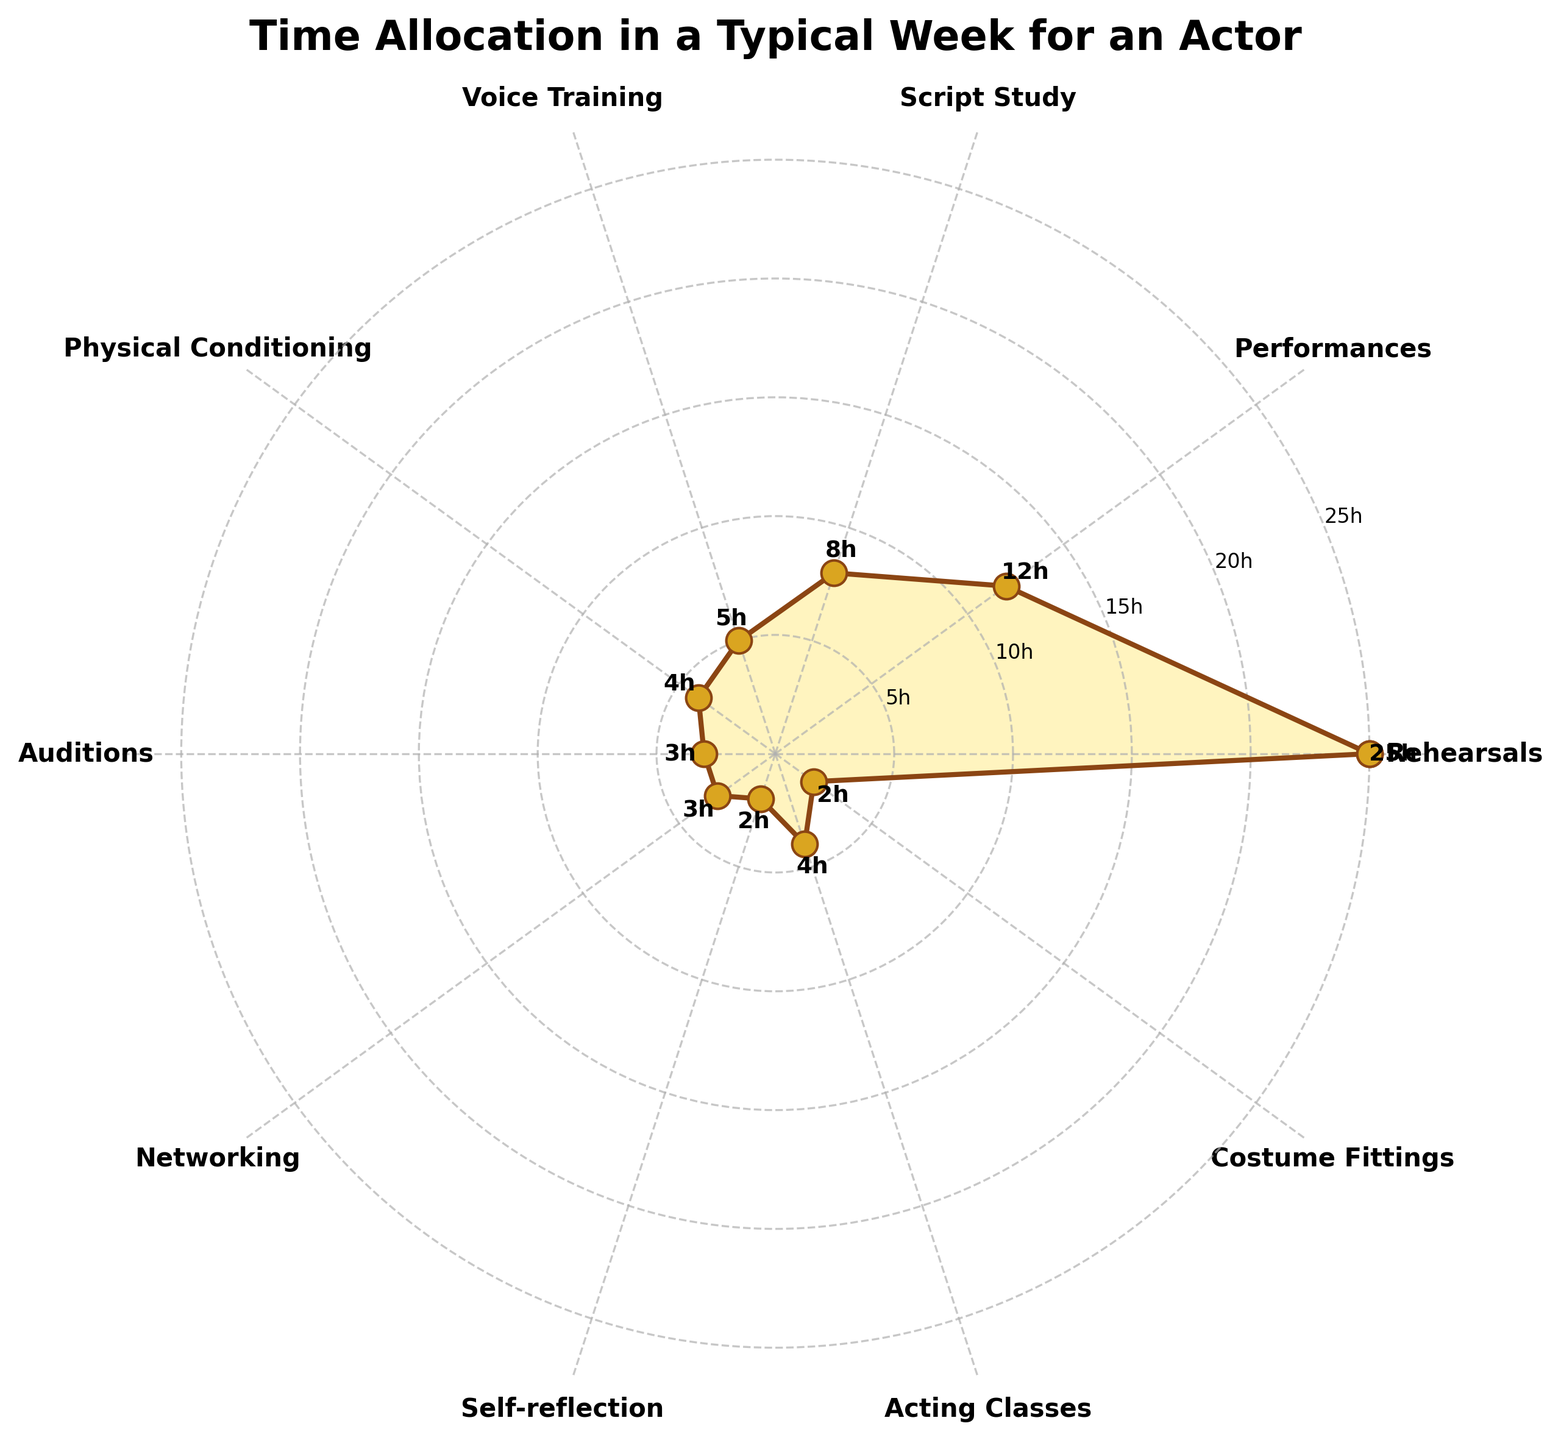What is the title of the figure? The title of the figure is written at the top. It is "Time Allocation in a Typical Week for an Actor".
Answer: Time Allocation in a Typical Week for an Actor How many activities are listed in the figure? By counting the distinct labels on the outer ring of the polar plot, we see there are 10 different activities listed.
Answer: 10 Which activity takes the most amount of time in a typical week? By observing the lengths of the spikes from the center of the polar chart, the "Rehearsals" spike is the longest, indicating it takes the most time.
Answer: Rehearsals What are the cumulative hours spent on Voice Training and Physical Conditioning? The hours spent on Voice Training and Physical Conditioning are 5 and 4, respectively. Adding these gives 5 + 4 = 9 hours.
Answer: 9 hours Which activity has the smallest allocation of hours, and how many hours are allocated to it? The shortest spike on the chart corresponds to "Self-reflection" and "Costume Fittings", which both have 2 hours.
Answer: Self-reflection and Costume Fittings, 2 hours each How much time is allocated to performances compared to script study? The line segment for Performances reaches 12 hours, while the line segment for Script Study reaches 8 hours. 12 - 8 = 4 hours more for Performances.
Answer: 4 hours more How many activities are allocated exactly 4 hours in a week? The labels closest to the 4-hour mark indicate that "Acting Classes" and "Physical Conditioning" are both allocated exactly 4 hours each.
Answer: 2 activities On average, how many hours are spent on activities related to personal development (including Voice Training, Physical Conditioning, and Acting Classes)? Summing the hours for these activities gives 5 (Voice Training) + 4 (Physical Conditioning) + 4 (Acting Classes) = 13 hours. There are 3 activities, so the average is 13 / 3 ≈ 4.33 hours.
Answer: Approximately 4.33 hours What percentage of the total allocated time is spent on Auditions? First, sum all activities' hours: 25 + 12 + 8 + 5 + 4 + 3 + 3 + 2 + 4 + 2 = 68 hours. Auditions take 3 hours. The percentage is (3 / 68) * 100 ≈ 4.41%.
Answer: Approximately 4.41% What is the difference in time allocation between Networking and Self-reflection? Networking gets 3 hours while Self-reflection gets 2 hours. The difference is 3 - 2 = 1 hour.
Answer: 1 hour 